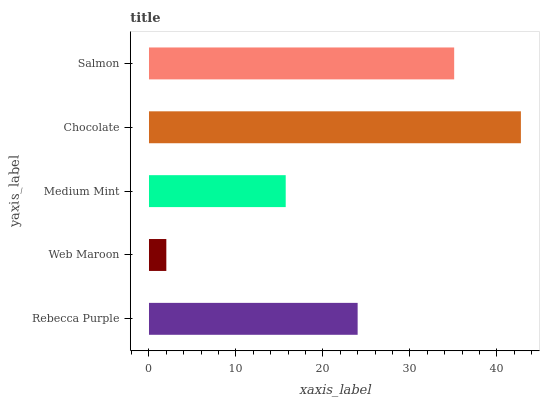Is Web Maroon the minimum?
Answer yes or no. Yes. Is Chocolate the maximum?
Answer yes or no. Yes. Is Medium Mint the minimum?
Answer yes or no. No. Is Medium Mint the maximum?
Answer yes or no. No. Is Medium Mint greater than Web Maroon?
Answer yes or no. Yes. Is Web Maroon less than Medium Mint?
Answer yes or no. Yes. Is Web Maroon greater than Medium Mint?
Answer yes or no. No. Is Medium Mint less than Web Maroon?
Answer yes or no. No. Is Rebecca Purple the high median?
Answer yes or no. Yes. Is Rebecca Purple the low median?
Answer yes or no. Yes. Is Salmon the high median?
Answer yes or no. No. Is Medium Mint the low median?
Answer yes or no. No. 